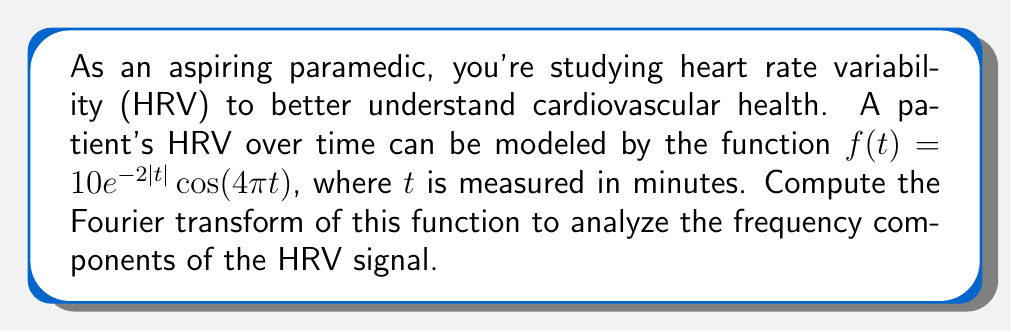Show me your answer to this math problem. To compute the Fourier transform of $f(t) = 10e^{-2|t|}\cos(4\pi t)$, we'll follow these steps:

1) The Fourier transform is defined as:
   $$F(\omega) = \int_{-\infty}^{\infty} f(t)e^{-i\omega t}dt$$

2) We can rewrite $\cos(4\pi t)$ using Euler's formula:
   $$\cos(4\pi t) = \frac{1}{2}(e^{i4\pi t} + e^{-i4\pi t})$$

3) Substituting this into our function:
   $$f(t) = 10e^{-2|t|} \cdot \frac{1}{2}(e^{i4\pi t} + e^{-i4\pi t}) = 5e^{-2|t|}e^{i4\pi t} + 5e^{-2|t|}e^{-i4\pi t}$$

4) Now we can split our integral:
   $$F(\omega) = 5\int_{-\infty}^{\infty} e^{-2|t|}e^{i4\pi t}e^{-i\omega t}dt + 5\int_{-\infty}^{\infty} e^{-2|t|}e^{-i4\pi t}e^{-i\omega t}dt$$

5) Simplifying the exponents:
   $$F(\omega) = 5\int_{-\infty}^{\infty} e^{-2|t|}e^{i(4\pi-\omega)t}dt + 5\int_{-\infty}^{\infty} e^{-2|t|}e^{-i(4\pi+\omega)t}dt$$

6) We can recognize these integrals as the Fourier transform of $e^{-2|t|}$, which is known to be:
   $$\mathcal{F}\{e^{-a|t|}\} = \frac{2a}{a^2 + \omega^2}$$

7) Applying this formula to our integrals:
   $$F(\omega) = 5\cdot\frac{4}{4 + (4\pi-\omega)^2} + 5\cdot\frac{4}{4 + (4\pi+\omega)^2}$$

8) Simplifying:
   $$F(\omega) = \frac{20}{4 + (4\pi-\omega)^2} + \frac{20}{4 + (4\pi+\omega)^2}$$

This is the Fourier transform of the given HRV function.
Answer: $$F(\omega) = \frac{20}{4 + (4\pi-\omega)^2} + \frac{20}{4 + (4\pi+\omega)^2}$$ 